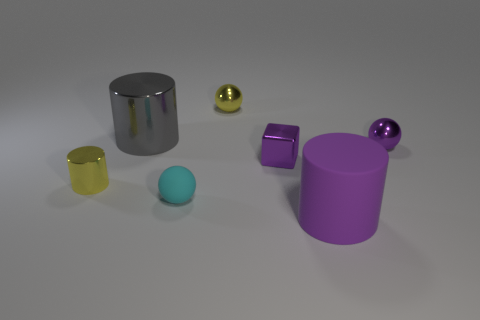Subtract all purple cylinders. Subtract all brown spheres. How many cylinders are left? 2 Add 3 tiny metallic balls. How many objects exist? 10 Subtract all blocks. How many objects are left? 6 Subtract all gray cylinders. Subtract all big gray metal cylinders. How many objects are left? 5 Add 3 purple cubes. How many purple cubes are left? 4 Add 1 tiny blue blocks. How many tiny blue blocks exist? 1 Subtract 0 cyan cylinders. How many objects are left? 7 